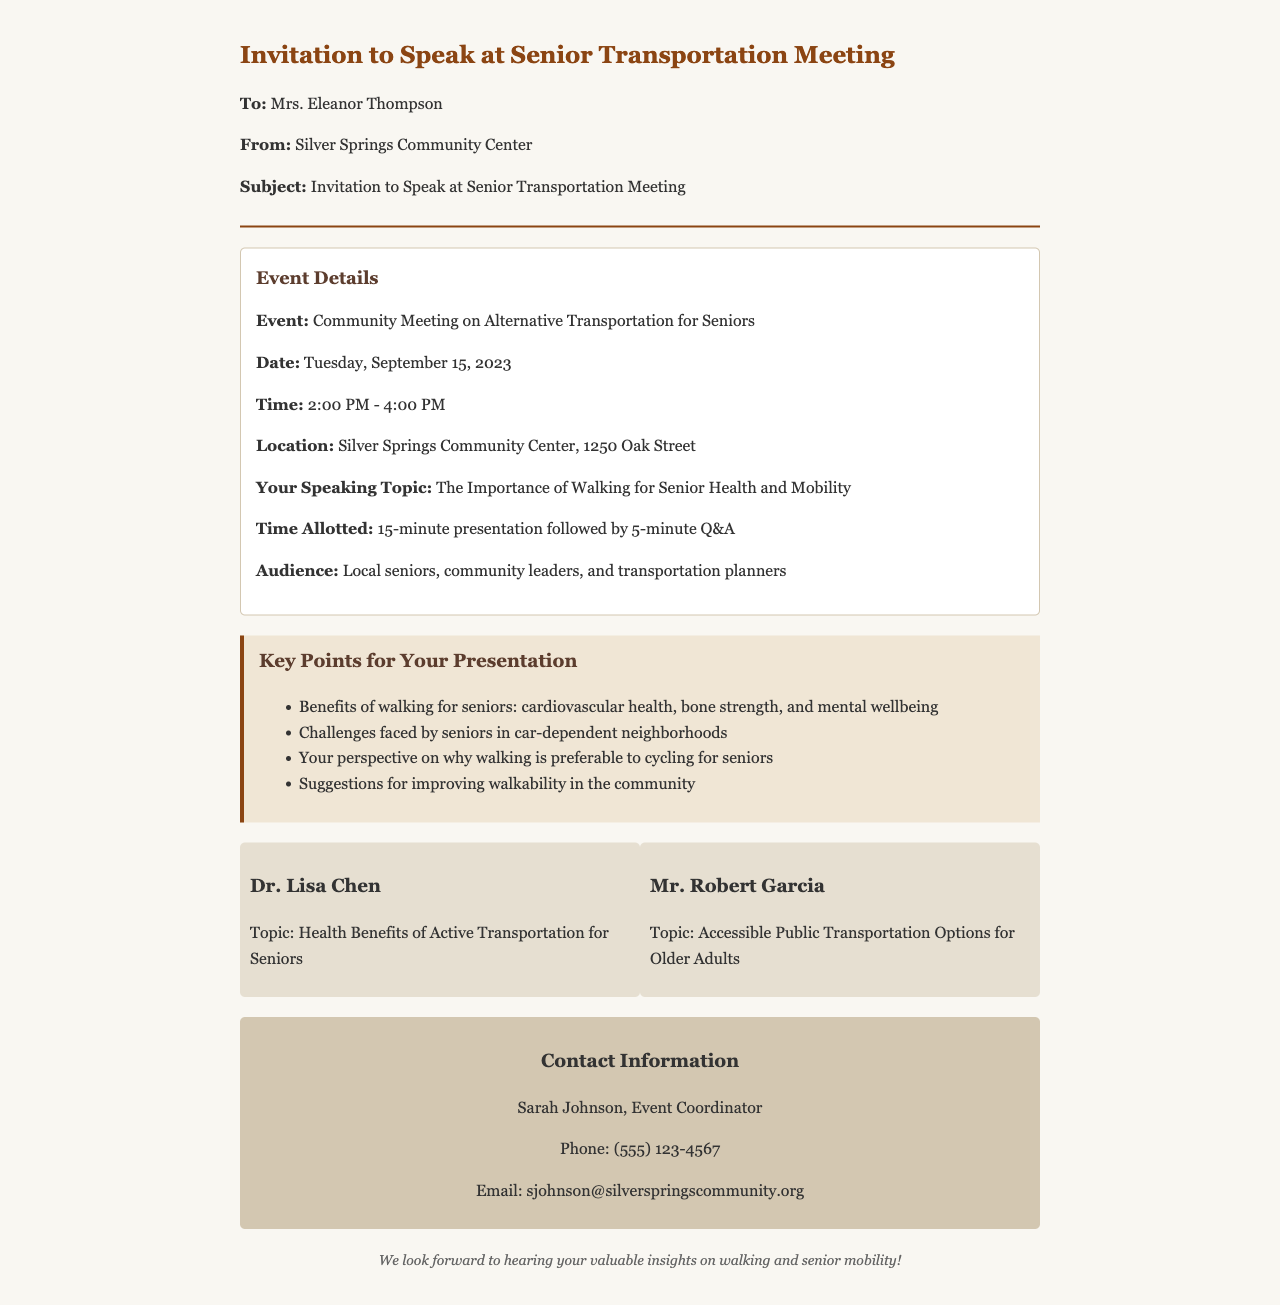What is the event title? The title of the event is explicitly mentioned in the document as the "Community Meeting on Alternative Transportation for Seniors."
Answer: Community Meeting on Alternative Transportation for Seniors What is the date of the meeting? The date is clearly stated in the document as "Tuesday, September 15, 2023."
Answer: Tuesday, September 15, 2023 Who is the speaking topic addressed to? The audience for the speaking topic is specifically mentioned as "Local seniors, community leaders, and transportation planners."
Answer: Local seniors, community leaders, and transportation planners How long is the allotted time for the presentation? The document states the time allotment as a "15-minute presentation followed by 5-minute Q&A."
Answer: 15-minute presentation What are the benefits of walking for seniors? The key points highlight several benefits among which cardiovascular health, bone strength, and mental wellbeing are specifically listed.
Answer: cardiovascular health, bone strength, and mental wellbeing What is the speaker's name? The invitation references "Mrs. Eleanor Thompson," who is the invitee to speak.
Answer: Mrs. Eleanor Thompson What suggestion can be made for the community? A suggestion referenced in the key points is to "improve walkability in the community."
Answer: improve walkability in the community Who is the event coordinator? The document specifies "Sarah Johnson" as the event coordinator responsible for organizing the meeting.
Answer: Sarah Johnson What time does the meeting start? The starting time of the meeting is explicitly mentioned as "2:00 PM."
Answer: 2:00 PM 